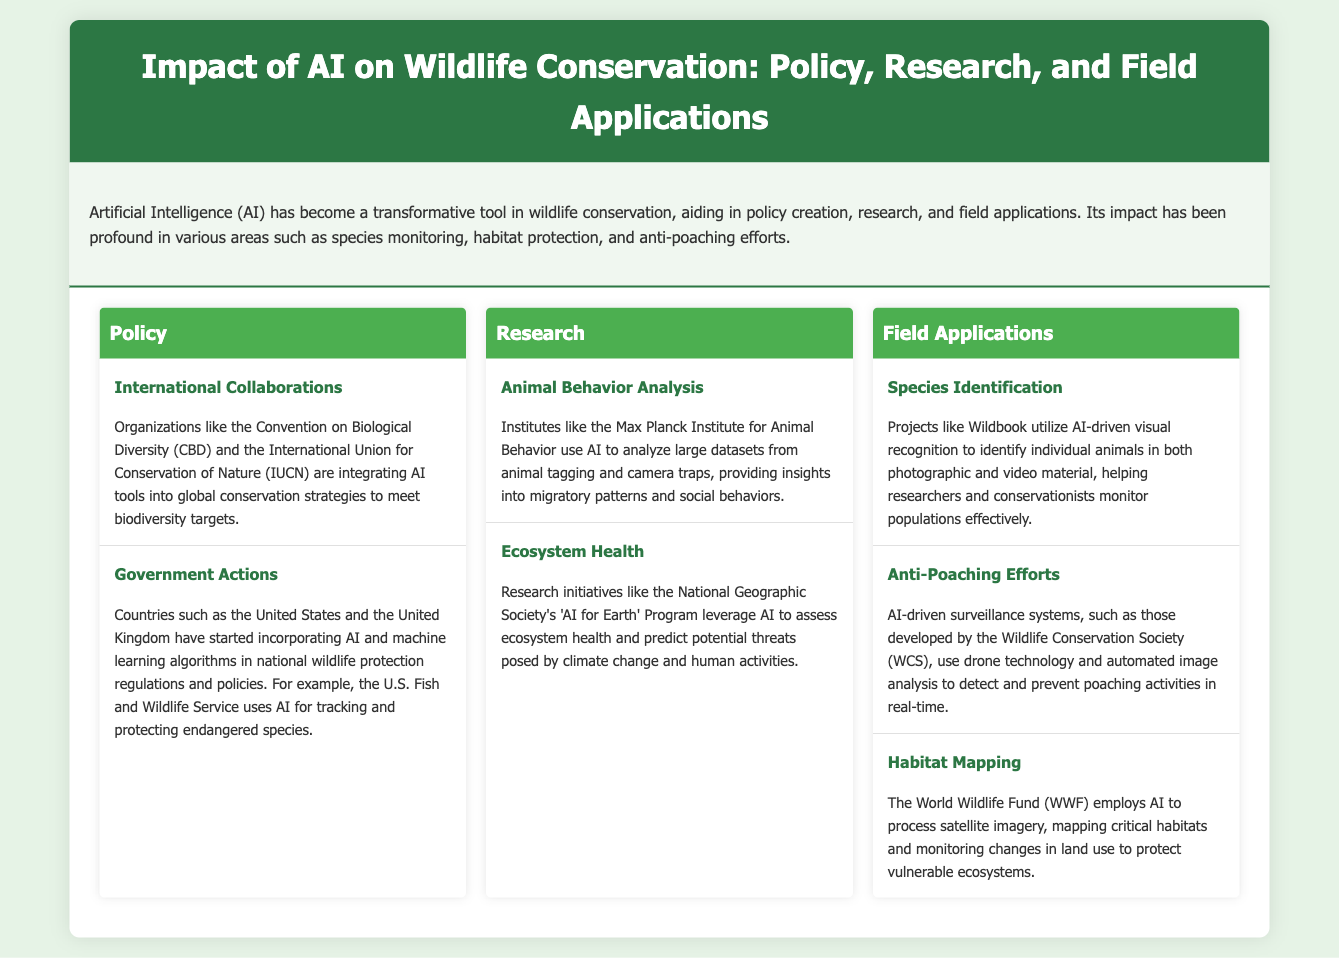What organizations are integrating AI tools for conservation? The organizations mentioned are the Convention on Biological Diversity (CBD) and the International Union for Conservation of Nature (IUCN).
Answer: CBD, IUCN Which country's Fish and Wildlife Service uses AI for tracking endangered species? The specific country mentioned is the United States, which uses AI through its Fish and Wildlife Service to track endangered species.
Answer: United States What research initiative does the National Geographic Society have focusing on AI? The research initiative is referred to as 'AI for Earth' Program, which leverages AI to assess ecosystem health.
Answer: AI for Earth What technology does the Wildlife Conservation Society employ to detect poaching? The technology used includes AI-driven surveillance systems that involve drone technology and automated image analysis.
Answer: Drones, automated image analysis How does the WWF utilize AI in wildlife conservation? The World Wildlife Fund employs AI to process satellite imagery for mapping critical habitats and monitoring land use changes.
Answer: Process satellite imagery What type of analysis does the Max Planck Institute for Animal Behavior conduct using AI? They conduct animal behavior analysis, focusing on insights from large datasets from animal tagging and camera traps.
Answer: Animal behavior analysis Which AI application helps in identifying individual animals? The project called Wildbook utilizes AI-driven visual recognition to identify individual animals in photographic and video material.
Answer: Wildbook What is a primary focus of government actions in wildlife protection? The primary focus mentioned is the incorporation of AI and machine learning algorithms in national wildlife protection regulations and policies.
Answer: AI, machine learning algorithms 